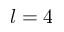<formula> <loc_0><loc_0><loc_500><loc_500>l = 4</formula> 